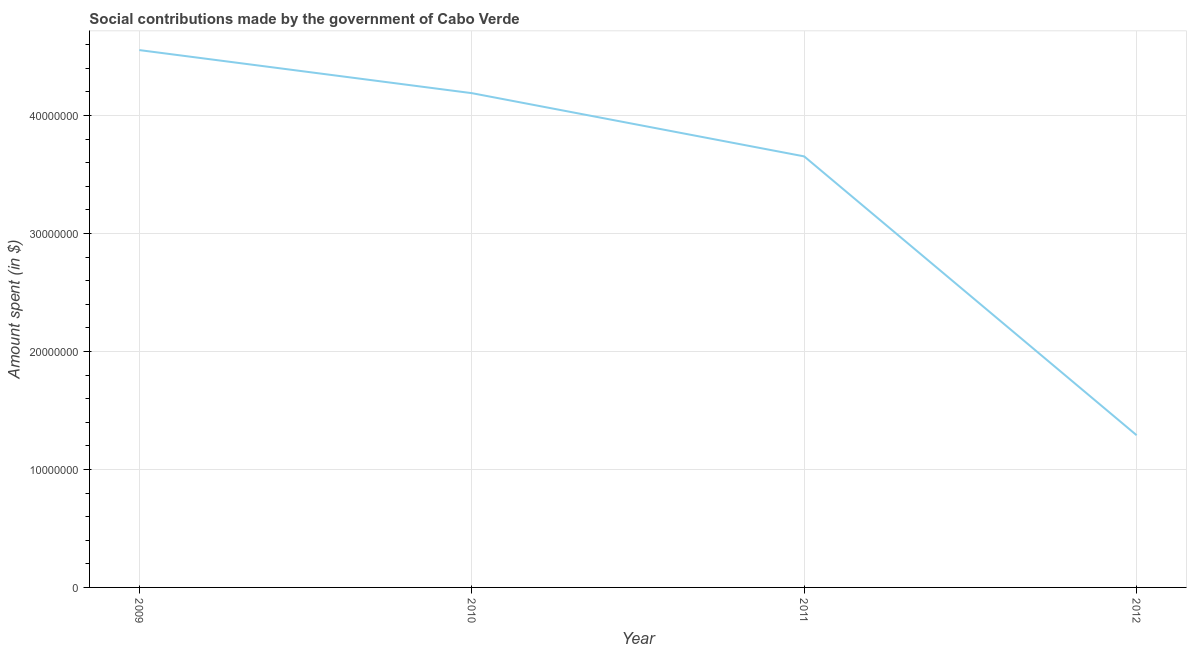What is the amount spent in making social contributions in 2012?
Offer a very short reply. 1.29e+07. Across all years, what is the maximum amount spent in making social contributions?
Your response must be concise. 4.56e+07. Across all years, what is the minimum amount spent in making social contributions?
Offer a very short reply. 1.29e+07. In which year was the amount spent in making social contributions minimum?
Provide a succinct answer. 2012. What is the sum of the amount spent in making social contributions?
Your response must be concise. 1.37e+08. What is the difference between the amount spent in making social contributions in 2009 and 2011?
Make the answer very short. 9.01e+06. What is the average amount spent in making social contributions per year?
Your response must be concise. 3.42e+07. What is the median amount spent in making social contributions?
Your answer should be compact. 3.92e+07. Do a majority of the years between 2010 and 2012 (inclusive) have amount spent in making social contributions greater than 12000000 $?
Ensure brevity in your answer.  Yes. What is the ratio of the amount spent in making social contributions in 2009 to that in 2012?
Your answer should be very brief. 3.53. What is the difference between the highest and the second highest amount spent in making social contributions?
Your answer should be compact. 3.65e+06. What is the difference between the highest and the lowest amount spent in making social contributions?
Your answer should be compact. 3.27e+07. How many lines are there?
Provide a succinct answer. 1. How many years are there in the graph?
Give a very brief answer. 4. What is the difference between two consecutive major ticks on the Y-axis?
Make the answer very short. 1.00e+07. Does the graph contain any zero values?
Keep it short and to the point. No. Does the graph contain grids?
Provide a short and direct response. Yes. What is the title of the graph?
Offer a terse response. Social contributions made by the government of Cabo Verde. What is the label or title of the Y-axis?
Make the answer very short. Amount spent (in $). What is the Amount spent (in $) of 2009?
Ensure brevity in your answer.  4.56e+07. What is the Amount spent (in $) in 2010?
Give a very brief answer. 4.19e+07. What is the Amount spent (in $) of 2011?
Keep it short and to the point. 3.65e+07. What is the Amount spent (in $) in 2012?
Make the answer very short. 1.29e+07. What is the difference between the Amount spent (in $) in 2009 and 2010?
Offer a terse response. 3.65e+06. What is the difference between the Amount spent (in $) in 2009 and 2011?
Offer a very short reply. 9.01e+06. What is the difference between the Amount spent (in $) in 2009 and 2012?
Your answer should be compact. 3.27e+07. What is the difference between the Amount spent (in $) in 2010 and 2011?
Give a very brief answer. 5.36e+06. What is the difference between the Amount spent (in $) in 2010 and 2012?
Offer a terse response. 2.90e+07. What is the difference between the Amount spent (in $) in 2011 and 2012?
Your answer should be very brief. 2.36e+07. What is the ratio of the Amount spent (in $) in 2009 to that in 2010?
Ensure brevity in your answer.  1.09. What is the ratio of the Amount spent (in $) in 2009 to that in 2011?
Offer a terse response. 1.25. What is the ratio of the Amount spent (in $) in 2009 to that in 2012?
Offer a terse response. 3.53. What is the ratio of the Amount spent (in $) in 2010 to that in 2011?
Keep it short and to the point. 1.15. What is the ratio of the Amount spent (in $) in 2010 to that in 2012?
Provide a short and direct response. 3.25. What is the ratio of the Amount spent (in $) in 2011 to that in 2012?
Provide a succinct answer. 2.83. 